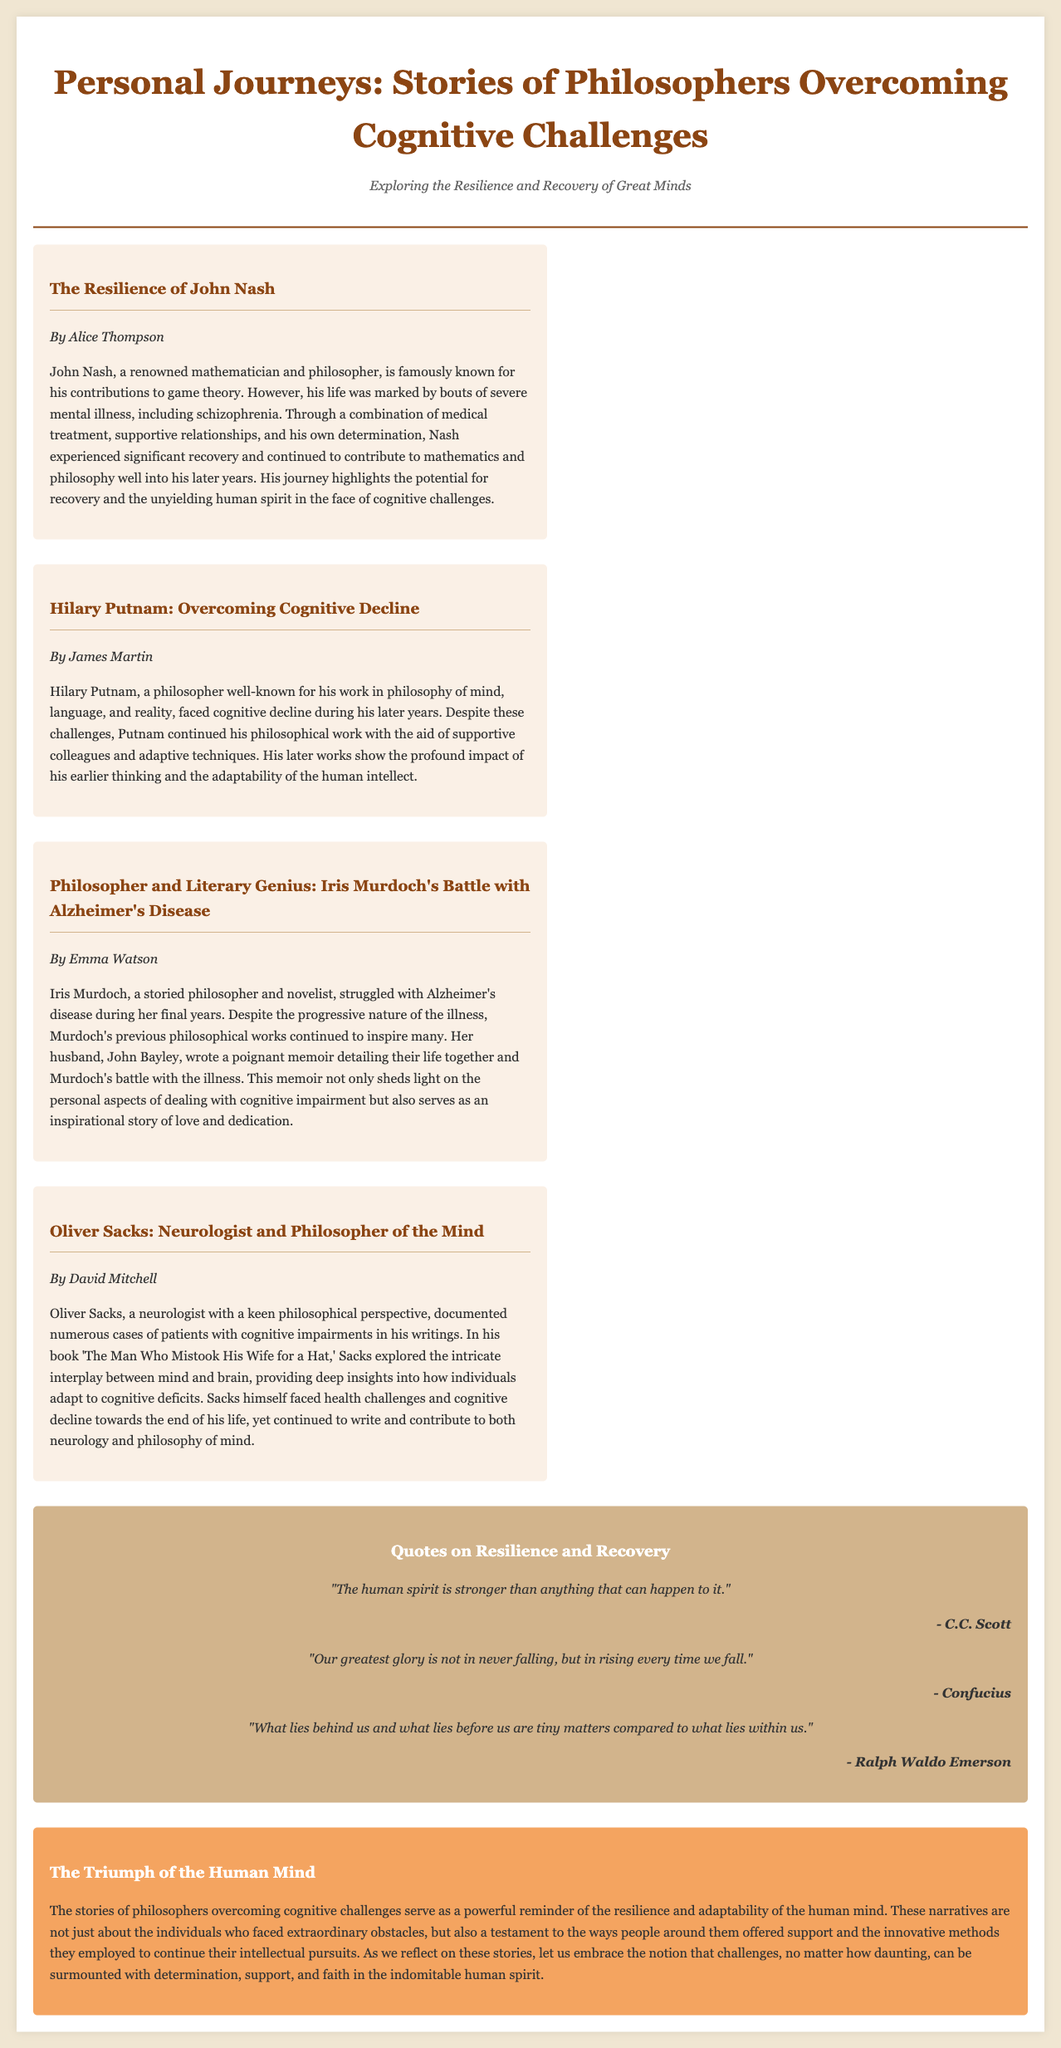what is the title of the document? The title is prominently displayed in the header section of the document.
Answer: Personal Journeys: Stories of Philosophers Overcoming Cognitive Challenges who wrote the article about John Nash? The author's name is provided below the title of the article.
Answer: Alice Thompson which philosopher is known for his work in philosophy of mind, language, and reality? This information is found in the article about Hilary Putnam.
Answer: Hilary Putnam what illness did Iris Murdoch struggle with? The article specifically mentions the illness in connection with her battle during her final years.
Answer: Alzheimer's disease who authored the memoir about Iris Murdoch? The document cites the author's relationship to Murdoch in the relevant article.
Answer: John Bayley which quote attributed to Confucius is mentioned in the sidebar? The quote's wording is provided in the sidebar section and attributed directly to the philosopher.
Answer: Our greatest glory is not in never falling, but in rising every time we fall how many articles are featured in the main content section? The number of articles can be counted in the main content area of the layout.
Answer: Four what overarching theme does the editorial highlight? The theme is summarized in the concluding paragraph of the editorial section.
Answer: Resilience and adaptability of the human mind 